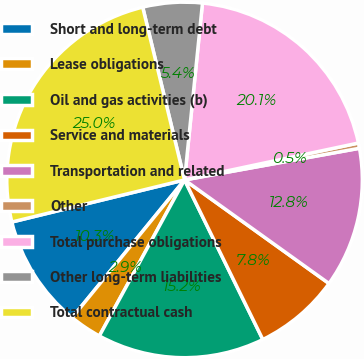Convert chart. <chart><loc_0><loc_0><loc_500><loc_500><pie_chart><fcel>Short and long-term debt<fcel>Lease obligations<fcel>Oil and gas activities (b)<fcel>Service and materials<fcel>Transportation and related<fcel>Other<fcel>Total purchase obligations<fcel>Other long-term liabilities<fcel>Total contractual cash<nl><fcel>10.3%<fcel>2.94%<fcel>15.21%<fcel>7.84%<fcel>12.75%<fcel>0.48%<fcel>20.06%<fcel>5.39%<fcel>25.02%<nl></chart> 